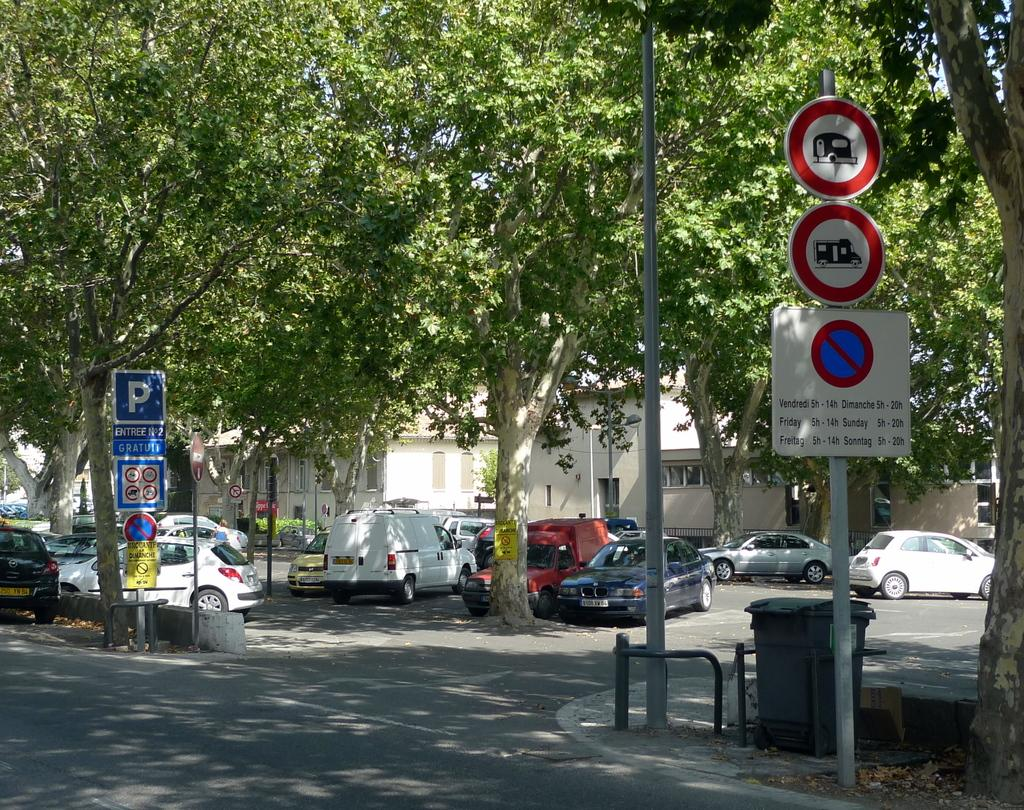<image>
Create a compact narrative representing the image presented. A blue sign with the letter P on it is near the entrance of a parking lot. 